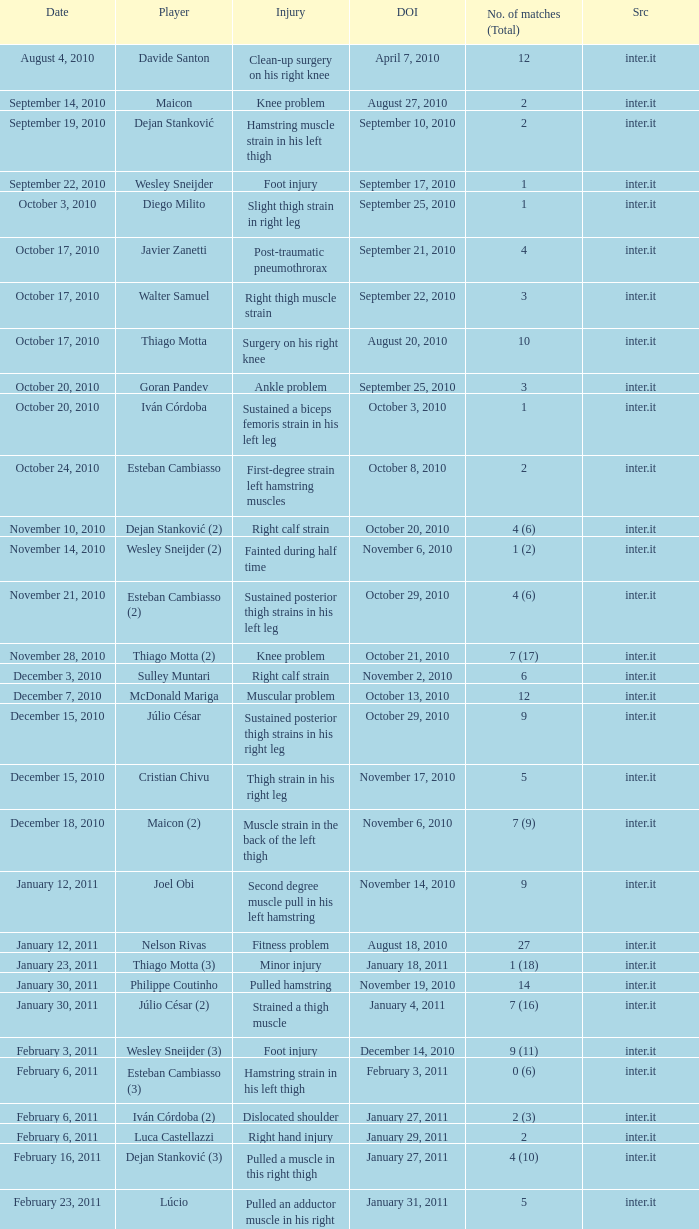What is the date of injury when the injury is sustained posterior thigh strains in his left leg? October 29, 2010. 